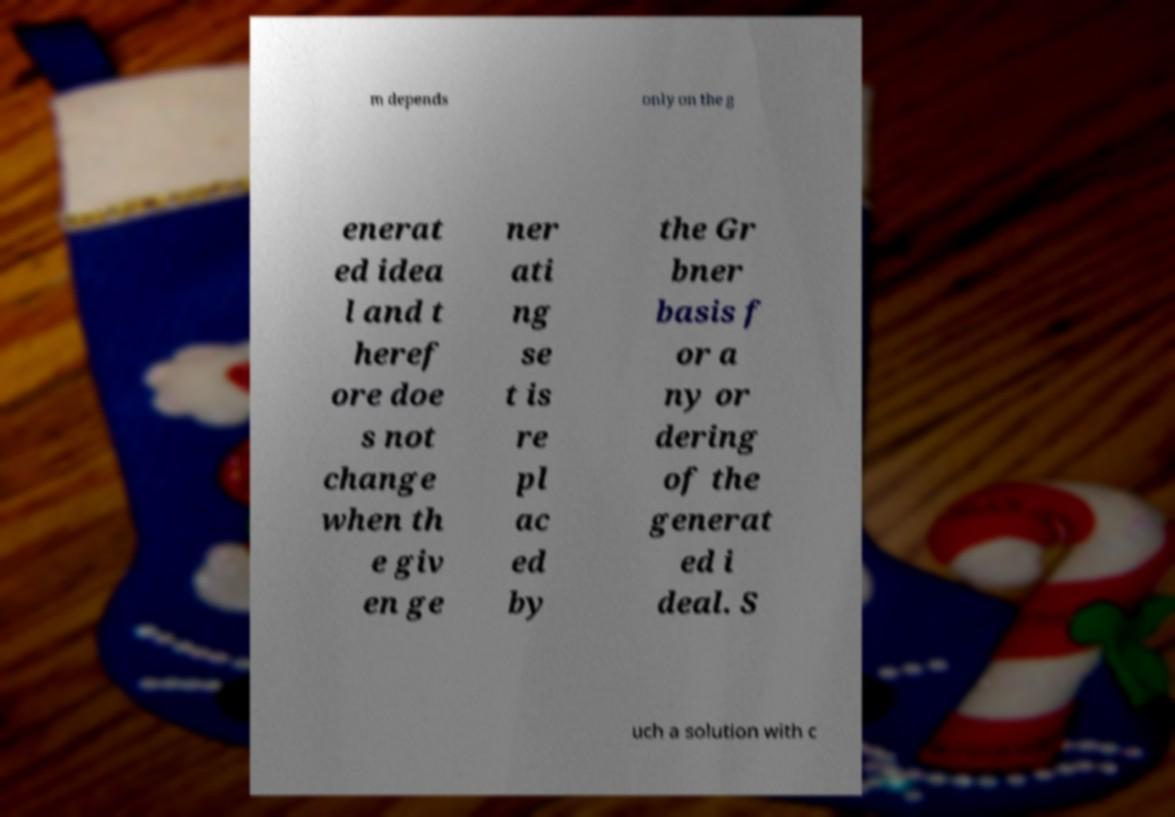Can you accurately transcribe the text from the provided image for me? m depends only on the g enerat ed idea l and t heref ore doe s not change when th e giv en ge ner ati ng se t is re pl ac ed by the Gr bner basis f or a ny or dering of the generat ed i deal. S uch a solution with c 